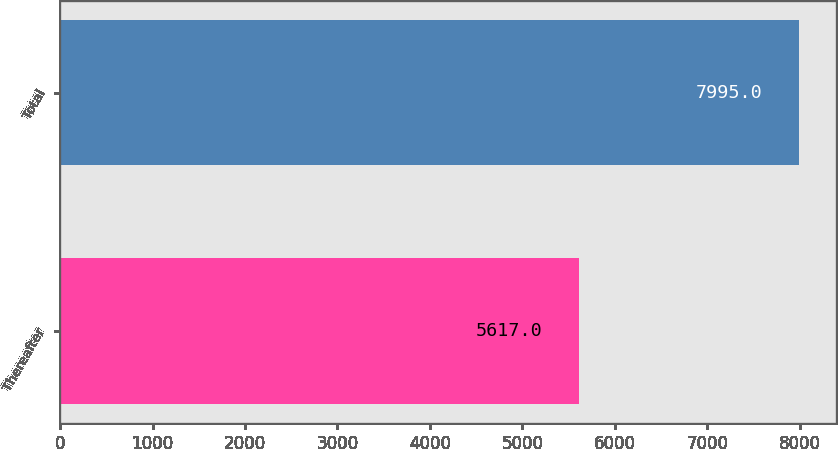Convert chart. <chart><loc_0><loc_0><loc_500><loc_500><bar_chart><fcel>Thereafter<fcel>Total<nl><fcel>5617<fcel>7995<nl></chart> 